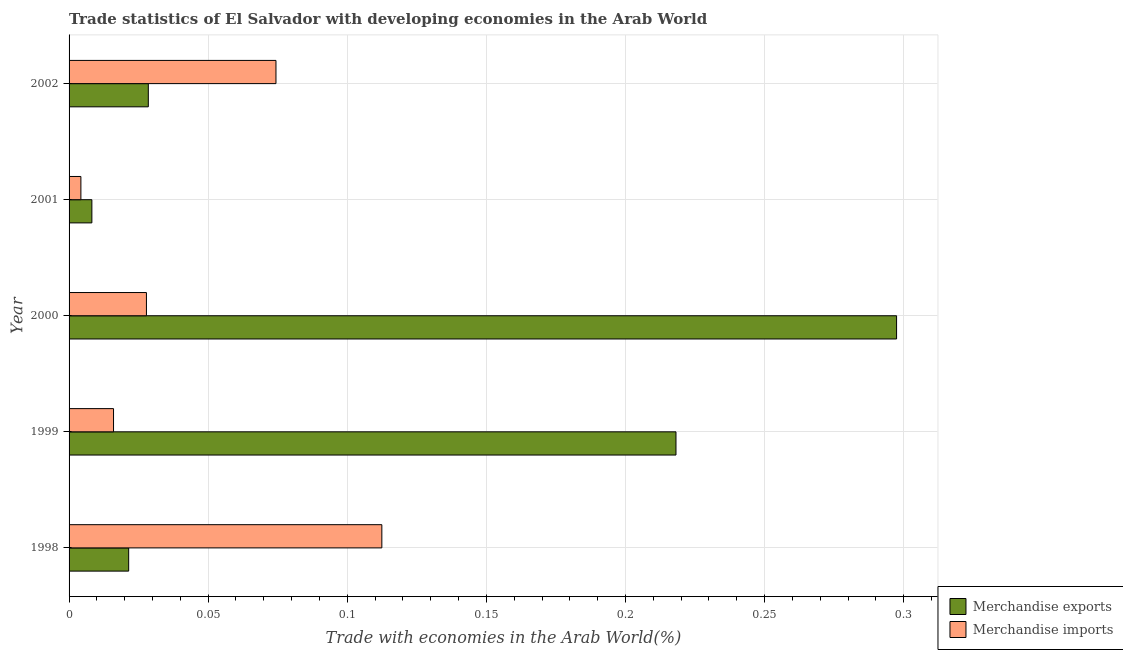How many groups of bars are there?
Give a very brief answer. 5. Are the number of bars per tick equal to the number of legend labels?
Provide a short and direct response. Yes. What is the label of the 3rd group of bars from the top?
Provide a short and direct response. 2000. What is the merchandise exports in 2000?
Provide a short and direct response. 0.3. Across all years, what is the maximum merchandise imports?
Make the answer very short. 0.11. Across all years, what is the minimum merchandise imports?
Make the answer very short. 0. In which year was the merchandise exports minimum?
Provide a succinct answer. 2001. What is the total merchandise imports in the graph?
Your answer should be compact. 0.23. What is the difference between the merchandise imports in 1999 and that in 2002?
Keep it short and to the point. -0.06. What is the difference between the merchandise exports in 1999 and the merchandise imports in 1998?
Make the answer very short. 0.11. What is the average merchandise exports per year?
Provide a short and direct response. 0.12. In the year 1999, what is the difference between the merchandise exports and merchandise imports?
Provide a short and direct response. 0.2. What is the ratio of the merchandise imports in 1999 to that in 2002?
Ensure brevity in your answer.  0.21. Is the difference between the merchandise imports in 1999 and 2002 greater than the difference between the merchandise exports in 1999 and 2002?
Give a very brief answer. No. What is the difference between the highest and the second highest merchandise imports?
Your answer should be compact. 0.04. What is the difference between the highest and the lowest merchandise exports?
Ensure brevity in your answer.  0.29. What does the 2nd bar from the bottom in 2001 represents?
Make the answer very short. Merchandise imports. Are all the bars in the graph horizontal?
Keep it short and to the point. Yes. What is the difference between two consecutive major ticks on the X-axis?
Offer a very short reply. 0.05. Are the values on the major ticks of X-axis written in scientific E-notation?
Provide a short and direct response. No. Where does the legend appear in the graph?
Your response must be concise. Bottom right. How many legend labels are there?
Make the answer very short. 2. What is the title of the graph?
Ensure brevity in your answer.  Trade statistics of El Salvador with developing economies in the Arab World. What is the label or title of the X-axis?
Provide a short and direct response. Trade with economies in the Arab World(%). What is the label or title of the Y-axis?
Offer a terse response. Year. What is the Trade with economies in the Arab World(%) in Merchandise exports in 1998?
Keep it short and to the point. 0.02. What is the Trade with economies in the Arab World(%) of Merchandise imports in 1998?
Provide a succinct answer. 0.11. What is the Trade with economies in the Arab World(%) of Merchandise exports in 1999?
Keep it short and to the point. 0.22. What is the Trade with economies in the Arab World(%) in Merchandise imports in 1999?
Offer a very short reply. 0.02. What is the Trade with economies in the Arab World(%) of Merchandise exports in 2000?
Your answer should be compact. 0.3. What is the Trade with economies in the Arab World(%) of Merchandise imports in 2000?
Your answer should be compact. 0.03. What is the Trade with economies in the Arab World(%) in Merchandise exports in 2001?
Your answer should be very brief. 0.01. What is the Trade with economies in the Arab World(%) of Merchandise imports in 2001?
Make the answer very short. 0. What is the Trade with economies in the Arab World(%) in Merchandise exports in 2002?
Your response must be concise. 0.03. What is the Trade with economies in the Arab World(%) of Merchandise imports in 2002?
Offer a terse response. 0.07. Across all years, what is the maximum Trade with economies in the Arab World(%) of Merchandise exports?
Your answer should be very brief. 0.3. Across all years, what is the maximum Trade with economies in the Arab World(%) of Merchandise imports?
Keep it short and to the point. 0.11. Across all years, what is the minimum Trade with economies in the Arab World(%) of Merchandise exports?
Your answer should be very brief. 0.01. Across all years, what is the minimum Trade with economies in the Arab World(%) in Merchandise imports?
Offer a very short reply. 0. What is the total Trade with economies in the Arab World(%) in Merchandise exports in the graph?
Ensure brevity in your answer.  0.57. What is the total Trade with economies in the Arab World(%) of Merchandise imports in the graph?
Give a very brief answer. 0.23. What is the difference between the Trade with economies in the Arab World(%) in Merchandise exports in 1998 and that in 1999?
Your answer should be very brief. -0.2. What is the difference between the Trade with economies in the Arab World(%) of Merchandise imports in 1998 and that in 1999?
Your answer should be very brief. 0.1. What is the difference between the Trade with economies in the Arab World(%) of Merchandise exports in 1998 and that in 2000?
Keep it short and to the point. -0.28. What is the difference between the Trade with economies in the Arab World(%) of Merchandise imports in 1998 and that in 2000?
Offer a very short reply. 0.08. What is the difference between the Trade with economies in the Arab World(%) of Merchandise exports in 1998 and that in 2001?
Make the answer very short. 0.01. What is the difference between the Trade with economies in the Arab World(%) of Merchandise imports in 1998 and that in 2001?
Offer a terse response. 0.11. What is the difference between the Trade with economies in the Arab World(%) of Merchandise exports in 1998 and that in 2002?
Provide a succinct answer. -0.01. What is the difference between the Trade with economies in the Arab World(%) in Merchandise imports in 1998 and that in 2002?
Ensure brevity in your answer.  0.04. What is the difference between the Trade with economies in the Arab World(%) in Merchandise exports in 1999 and that in 2000?
Give a very brief answer. -0.08. What is the difference between the Trade with economies in the Arab World(%) of Merchandise imports in 1999 and that in 2000?
Provide a short and direct response. -0.01. What is the difference between the Trade with economies in the Arab World(%) of Merchandise exports in 1999 and that in 2001?
Make the answer very short. 0.21. What is the difference between the Trade with economies in the Arab World(%) of Merchandise imports in 1999 and that in 2001?
Provide a succinct answer. 0.01. What is the difference between the Trade with economies in the Arab World(%) of Merchandise exports in 1999 and that in 2002?
Offer a terse response. 0.19. What is the difference between the Trade with economies in the Arab World(%) of Merchandise imports in 1999 and that in 2002?
Your answer should be compact. -0.06. What is the difference between the Trade with economies in the Arab World(%) in Merchandise exports in 2000 and that in 2001?
Keep it short and to the point. 0.29. What is the difference between the Trade with economies in the Arab World(%) in Merchandise imports in 2000 and that in 2001?
Your response must be concise. 0.02. What is the difference between the Trade with economies in the Arab World(%) in Merchandise exports in 2000 and that in 2002?
Offer a very short reply. 0.27. What is the difference between the Trade with economies in the Arab World(%) in Merchandise imports in 2000 and that in 2002?
Offer a terse response. -0.05. What is the difference between the Trade with economies in the Arab World(%) of Merchandise exports in 2001 and that in 2002?
Offer a terse response. -0.02. What is the difference between the Trade with economies in the Arab World(%) in Merchandise imports in 2001 and that in 2002?
Your answer should be compact. -0.07. What is the difference between the Trade with economies in the Arab World(%) of Merchandise exports in 1998 and the Trade with economies in the Arab World(%) of Merchandise imports in 1999?
Your answer should be compact. 0.01. What is the difference between the Trade with economies in the Arab World(%) of Merchandise exports in 1998 and the Trade with economies in the Arab World(%) of Merchandise imports in 2000?
Provide a succinct answer. -0.01. What is the difference between the Trade with economies in the Arab World(%) in Merchandise exports in 1998 and the Trade with economies in the Arab World(%) in Merchandise imports in 2001?
Your answer should be compact. 0.02. What is the difference between the Trade with economies in the Arab World(%) in Merchandise exports in 1998 and the Trade with economies in the Arab World(%) in Merchandise imports in 2002?
Provide a succinct answer. -0.05. What is the difference between the Trade with economies in the Arab World(%) of Merchandise exports in 1999 and the Trade with economies in the Arab World(%) of Merchandise imports in 2000?
Your response must be concise. 0.19. What is the difference between the Trade with economies in the Arab World(%) of Merchandise exports in 1999 and the Trade with economies in the Arab World(%) of Merchandise imports in 2001?
Provide a succinct answer. 0.21. What is the difference between the Trade with economies in the Arab World(%) in Merchandise exports in 1999 and the Trade with economies in the Arab World(%) in Merchandise imports in 2002?
Your response must be concise. 0.14. What is the difference between the Trade with economies in the Arab World(%) in Merchandise exports in 2000 and the Trade with economies in the Arab World(%) in Merchandise imports in 2001?
Offer a terse response. 0.29. What is the difference between the Trade with economies in the Arab World(%) of Merchandise exports in 2000 and the Trade with economies in the Arab World(%) of Merchandise imports in 2002?
Keep it short and to the point. 0.22. What is the difference between the Trade with economies in the Arab World(%) of Merchandise exports in 2001 and the Trade with economies in the Arab World(%) of Merchandise imports in 2002?
Keep it short and to the point. -0.07. What is the average Trade with economies in the Arab World(%) of Merchandise exports per year?
Your answer should be compact. 0.11. What is the average Trade with economies in the Arab World(%) of Merchandise imports per year?
Your answer should be very brief. 0.05. In the year 1998, what is the difference between the Trade with economies in the Arab World(%) in Merchandise exports and Trade with economies in the Arab World(%) in Merchandise imports?
Give a very brief answer. -0.09. In the year 1999, what is the difference between the Trade with economies in the Arab World(%) of Merchandise exports and Trade with economies in the Arab World(%) of Merchandise imports?
Your answer should be very brief. 0.2. In the year 2000, what is the difference between the Trade with economies in the Arab World(%) in Merchandise exports and Trade with economies in the Arab World(%) in Merchandise imports?
Your answer should be compact. 0.27. In the year 2001, what is the difference between the Trade with economies in the Arab World(%) of Merchandise exports and Trade with economies in the Arab World(%) of Merchandise imports?
Your response must be concise. 0. In the year 2002, what is the difference between the Trade with economies in the Arab World(%) in Merchandise exports and Trade with economies in the Arab World(%) in Merchandise imports?
Ensure brevity in your answer.  -0.05. What is the ratio of the Trade with economies in the Arab World(%) of Merchandise exports in 1998 to that in 1999?
Provide a succinct answer. 0.1. What is the ratio of the Trade with economies in the Arab World(%) in Merchandise imports in 1998 to that in 1999?
Offer a very short reply. 7.04. What is the ratio of the Trade with economies in the Arab World(%) in Merchandise exports in 1998 to that in 2000?
Offer a terse response. 0.07. What is the ratio of the Trade with economies in the Arab World(%) of Merchandise imports in 1998 to that in 2000?
Offer a terse response. 4.04. What is the ratio of the Trade with economies in the Arab World(%) in Merchandise exports in 1998 to that in 2001?
Keep it short and to the point. 2.61. What is the ratio of the Trade with economies in the Arab World(%) in Merchandise imports in 1998 to that in 2001?
Provide a short and direct response. 26.48. What is the ratio of the Trade with economies in the Arab World(%) in Merchandise exports in 1998 to that in 2002?
Your answer should be compact. 0.75. What is the ratio of the Trade with economies in the Arab World(%) in Merchandise imports in 1998 to that in 2002?
Make the answer very short. 1.51. What is the ratio of the Trade with economies in the Arab World(%) in Merchandise exports in 1999 to that in 2000?
Offer a terse response. 0.73. What is the ratio of the Trade with economies in the Arab World(%) of Merchandise imports in 1999 to that in 2000?
Offer a terse response. 0.57. What is the ratio of the Trade with economies in the Arab World(%) in Merchandise exports in 1999 to that in 2001?
Your answer should be very brief. 26.61. What is the ratio of the Trade with economies in the Arab World(%) of Merchandise imports in 1999 to that in 2001?
Keep it short and to the point. 3.76. What is the ratio of the Trade with economies in the Arab World(%) of Merchandise exports in 1999 to that in 2002?
Your answer should be very brief. 7.66. What is the ratio of the Trade with economies in the Arab World(%) of Merchandise imports in 1999 to that in 2002?
Give a very brief answer. 0.21. What is the ratio of the Trade with economies in the Arab World(%) in Merchandise exports in 2000 to that in 2001?
Keep it short and to the point. 36.28. What is the ratio of the Trade with economies in the Arab World(%) in Merchandise imports in 2000 to that in 2001?
Provide a short and direct response. 6.55. What is the ratio of the Trade with economies in the Arab World(%) in Merchandise exports in 2000 to that in 2002?
Offer a terse response. 10.44. What is the ratio of the Trade with economies in the Arab World(%) of Merchandise imports in 2000 to that in 2002?
Keep it short and to the point. 0.37. What is the ratio of the Trade with economies in the Arab World(%) in Merchandise exports in 2001 to that in 2002?
Give a very brief answer. 0.29. What is the ratio of the Trade with economies in the Arab World(%) of Merchandise imports in 2001 to that in 2002?
Keep it short and to the point. 0.06. What is the difference between the highest and the second highest Trade with economies in the Arab World(%) in Merchandise exports?
Offer a terse response. 0.08. What is the difference between the highest and the second highest Trade with economies in the Arab World(%) of Merchandise imports?
Keep it short and to the point. 0.04. What is the difference between the highest and the lowest Trade with economies in the Arab World(%) in Merchandise exports?
Your answer should be very brief. 0.29. What is the difference between the highest and the lowest Trade with economies in the Arab World(%) of Merchandise imports?
Provide a succinct answer. 0.11. 